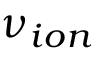<formula> <loc_0><loc_0><loc_500><loc_500>\nu _ { i o n }</formula> 